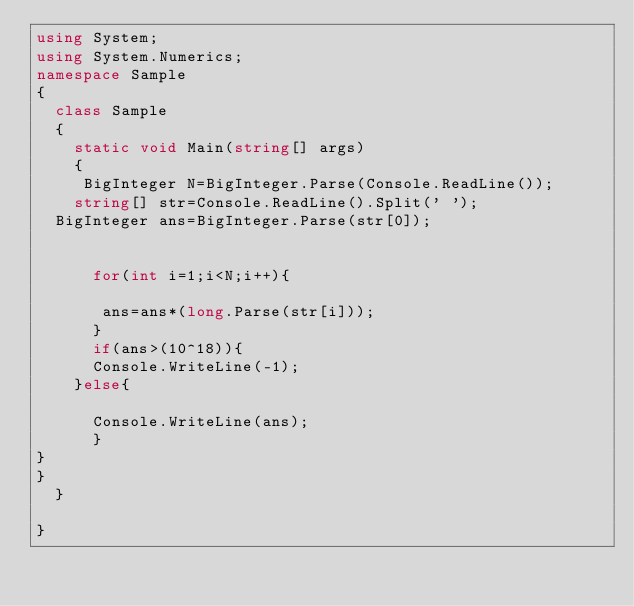Convert code to text. <code><loc_0><loc_0><loc_500><loc_500><_C#_>using System;
using System.Numerics; 
namespace Sample
{
  class Sample
  {
    static void Main(string[] args)
    {
     BigInteger N=BigInteger.Parse(Console.ReadLine());
    string[] str=Console.ReadLine().Split(' ');
	BigInteger ans=BigInteger.Parse(str[0]);


      for(int i=1;i<N;i++){

       ans=ans*(long.Parse(str[i]));
      }
      if(ans>(10^18)){
      Console.WriteLine(-1);
    }else{

      Console.WriteLine(ans);
      }
}
}
  }

}</code> 